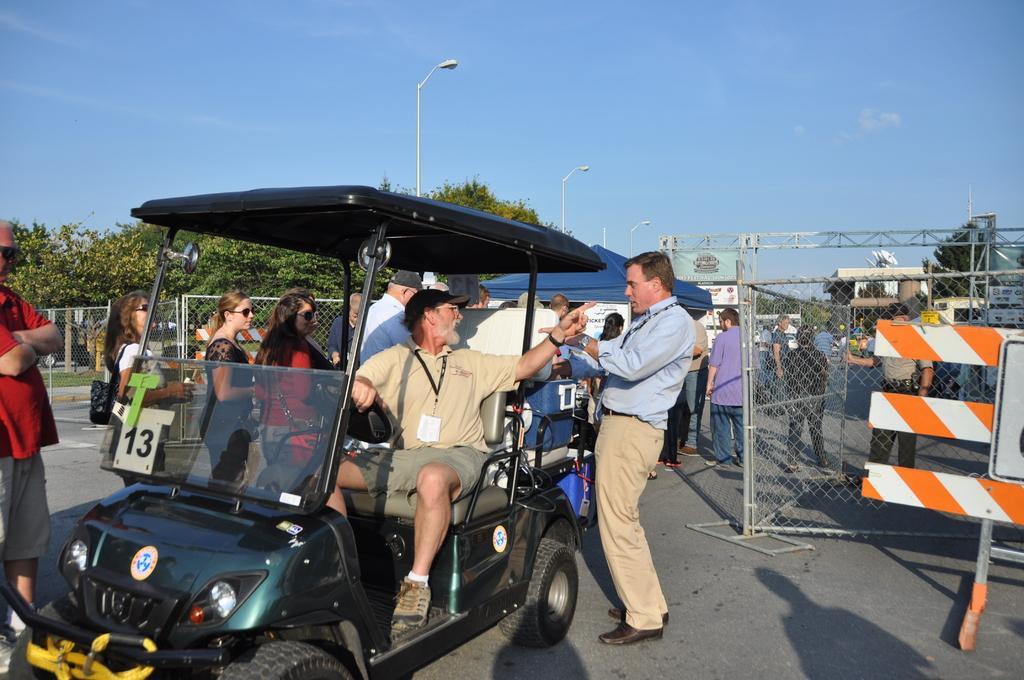Describe this image in one or two sentences. In this picture we can see sky, fencing covered with trees, and here is the person sitting on a vehicle and holding a hand on steering, and the person standing on the road, and there are group of people standing beside and here is the fencing. 